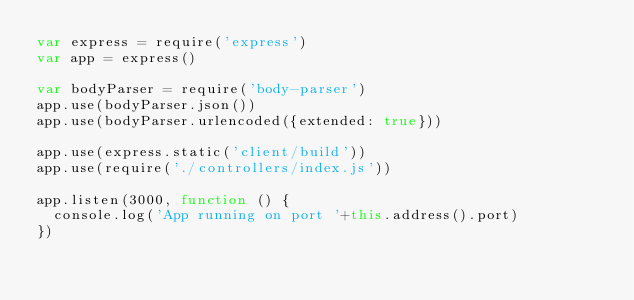Convert code to text. <code><loc_0><loc_0><loc_500><loc_500><_JavaScript_>var express = require('express')
var app = express()

var bodyParser = require('body-parser')
app.use(bodyParser.json())
app.use(bodyParser.urlencoded({extended: true}))

app.use(express.static('client/build'))
app.use(require('./controllers/index.js'))

app.listen(3000, function () {
  console.log('App running on port '+this.address().port)
})
</code> 